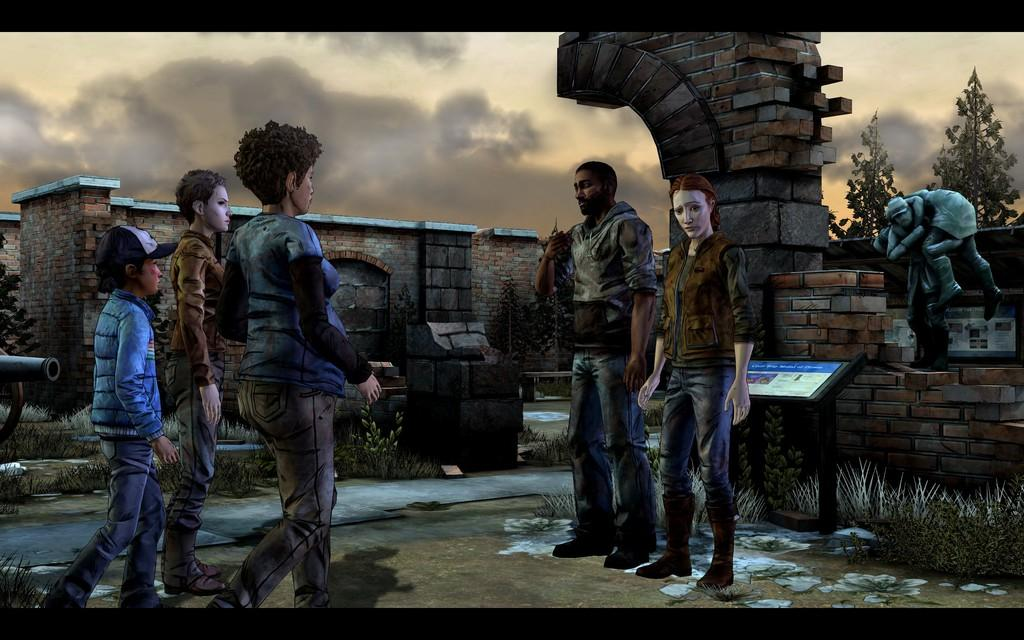What type of image is being described? The image is an animated picture. What can be seen in the image besides the animated elements? There are persons standing in the image, along with a sculpture. What can be seen in the background of the image? There are buildings and the sky visible in the background of the image. What is the condition of the sky in the image? The sky is visible in the background of the image, and clouds are present. What type of party is being held in the image? There is no party depicted in the image; it features an animated scene with persons, a sculpture, buildings, and a cloudy sky. Can you tell me how many volleyball games are being played in the image? There is no volleyball game or any reference to sports in the image. 